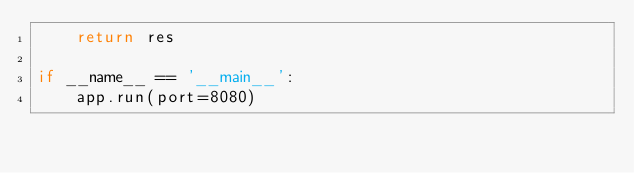Convert code to text. <code><loc_0><loc_0><loc_500><loc_500><_Python_>    return res

if __name__ == '__main__':
    app.run(port=8080)</code> 